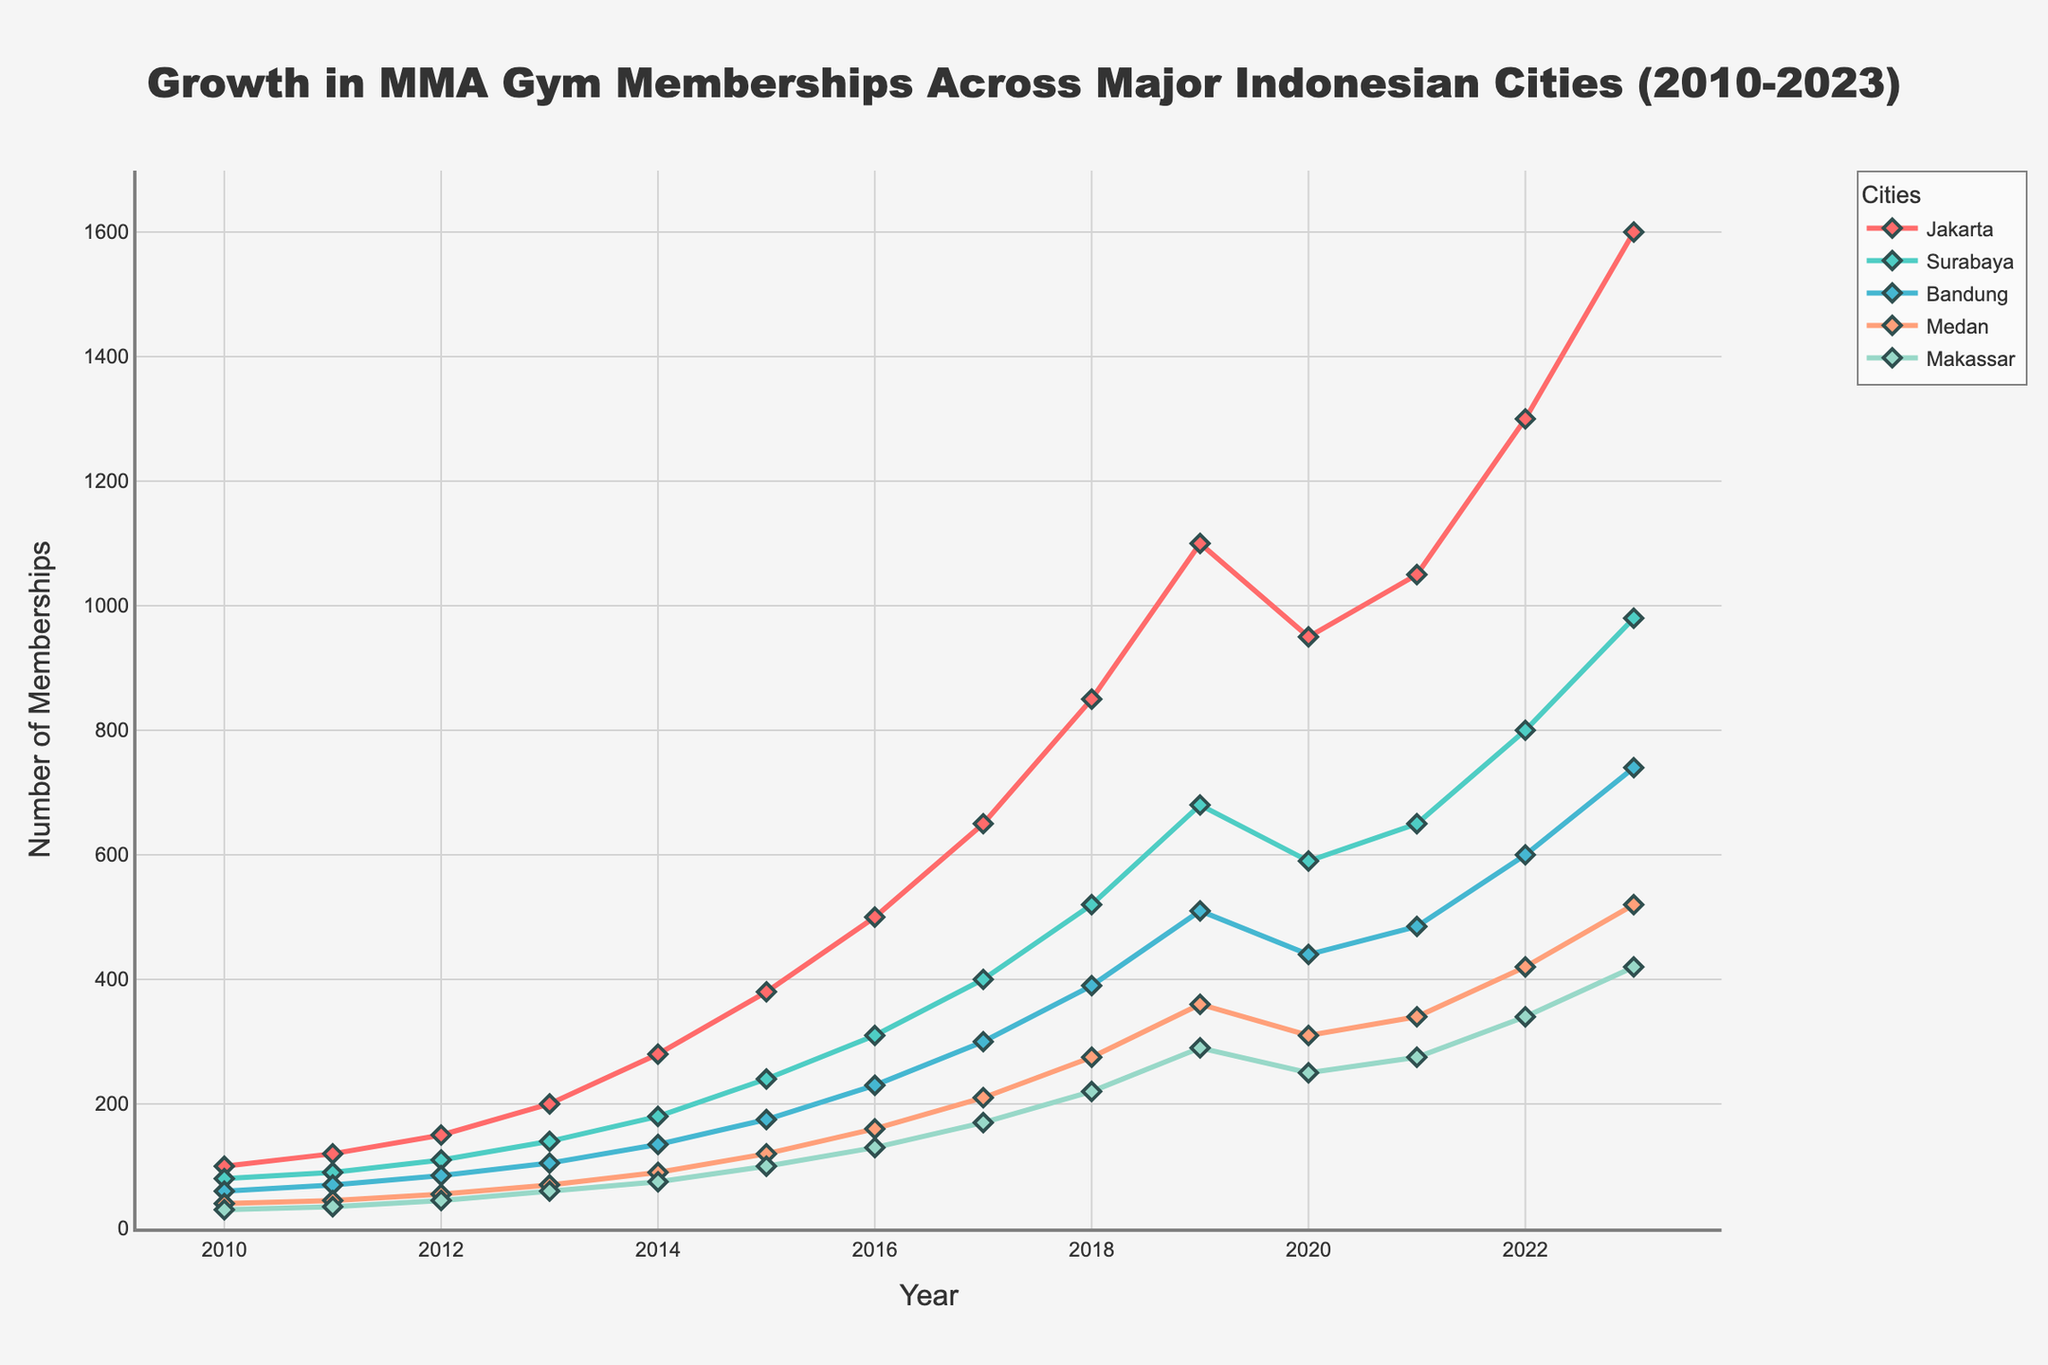What city had the highest gym membership in 2023? By looking at the data points for the year 2023, we can see the values for each city. Jakarta has the highest membership with 1600.
Answer: Jakarta Which city experienced the smallest growth in memberships between 2010 and 2023? To find the city with the smallest growth, we need to compare the values from 2010 and 2023 for each city and calculate the difference. Makassar grew from 30 in 2010 to 420 in 2023, which is the smallest growth.
Answer: Makassar Did any city experience a decline in memberships in any year? By observing the line chart, we can see if any lines dip downwards. The chart shows that Jakarta, Surabaya, Bandung, Medan, and Makassar all dipped in 2020.
Answer: Yes Which city had the biggest percentage increase in memberships from 2010 to 2023? To calculate the percentage increase, use the formula: (Final Value - Initial Value) / Initial Value * 100%. For Makassar, it is ((420 - 30) / 30) * 100% = 1300%. After comparing all cities, Makassar has the highest percentage increase.
Answer: Makassar Compare the memberships of Jakarta and Surabaya in 2013. Which city had more members and by how much? In 2013, Jakarta had 200 memberships, and Surabaya had 140 memberships. The difference is 200 - 140 = 60 memberships.
Answer: Jakarta by 60 How many total memberships did Medan have in 2019 and 2023 combined? To find the sum, add the memberships of Medan for 2019 and 2023: 360 + 520 = 880
Answer: 880 What year did Bandung surpass 200 memberships? By analyzing the line for Bandung, it surpassed 200 memberships around 2017 with 300 memberships.
Answer: 2017 What is the average membership for Makassar from 2010 to 2023? To find the average, sum all the memberships of Makassar from 2010 to 2023 and divide by the number of years (14). Sum = 30+35+45+60+75+100+130+170+220+290+250+275+340+420 = 2440. Average = 2440 / 14 ≈ 174.3
Answer: 174.3 In which year did Jakarta have approximately double the memberships of Bandung? By checking the values, in 2018, Jakarta had 850 and Bandung had 390. 850 is approximately double 390.
Answer: 2018 What was the combined membership for all cities in 2023? Add the memberships across all cities for 2023: 1600 (Jakarta) + 980 (Surabaya) + 740 (Bandung) + 520 (Medan) + 420 (Makassar) = 4260.
Answer: 4260 